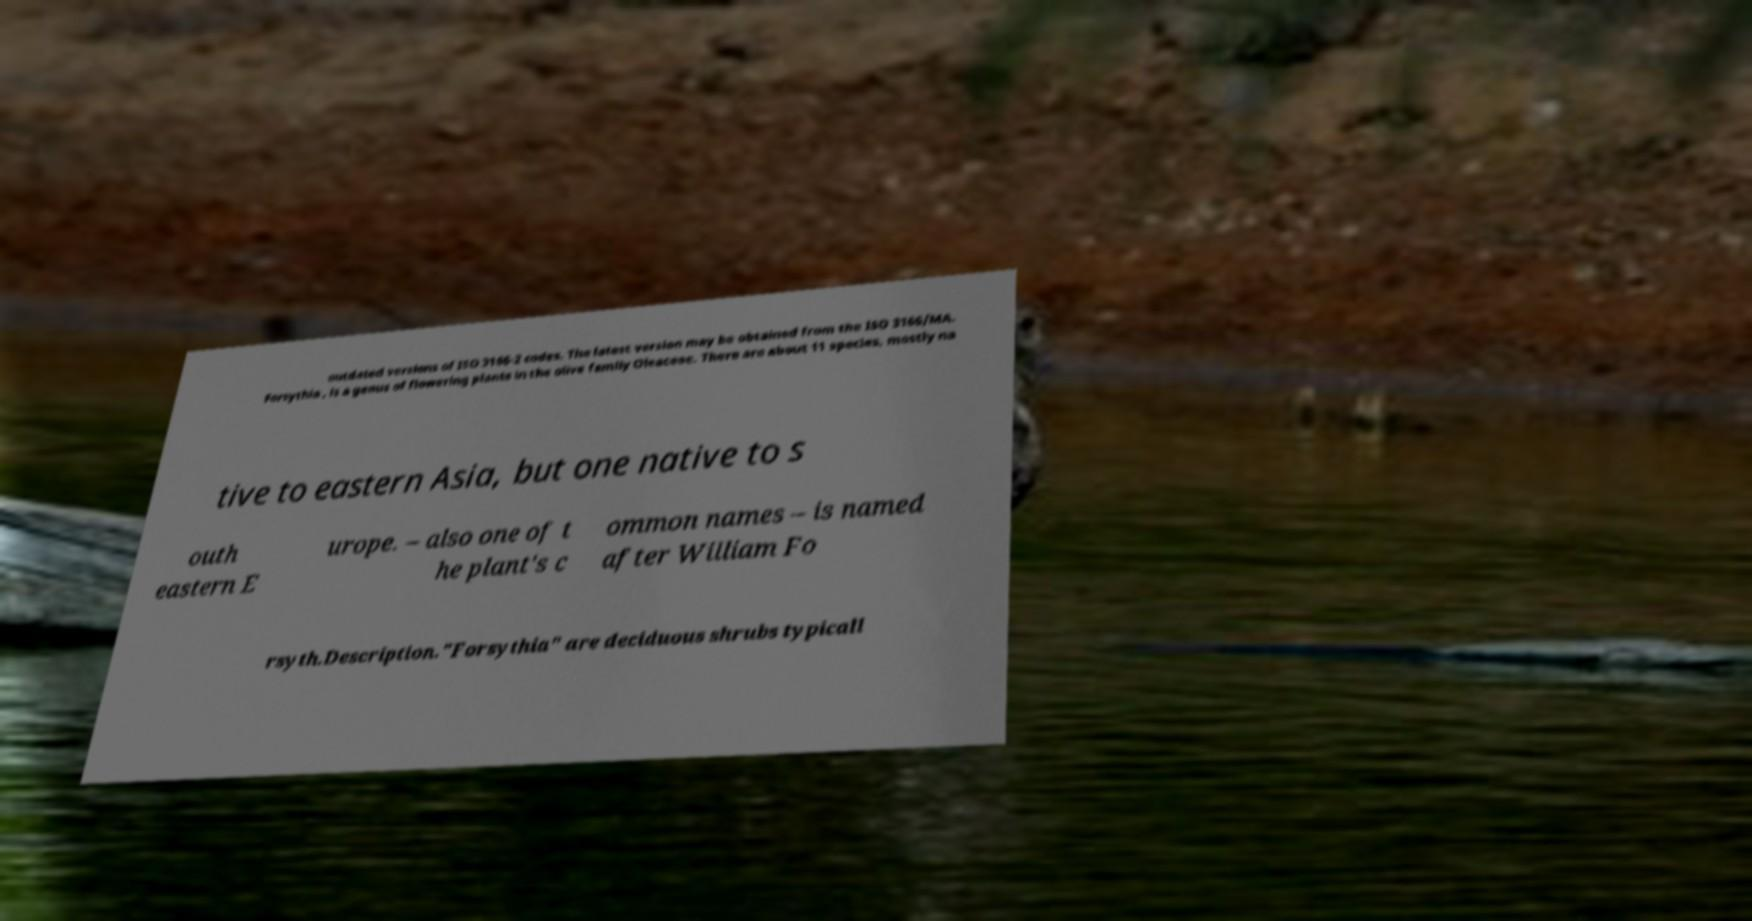Can you accurately transcribe the text from the provided image for me? outdated versions of ISO 3166-2 codes. The latest version may be obtained from the ISO 3166/MA. Forsythia , is a genus of flowering plants in the olive family Oleaceae. There are about 11 species, mostly na tive to eastern Asia, but one native to s outh eastern E urope. – also one of t he plant's c ommon names – is named after William Fo rsyth.Description."Forsythia" are deciduous shrubs typicall 